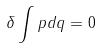<formula> <loc_0><loc_0><loc_500><loc_500>\delta \int p d q = 0</formula> 